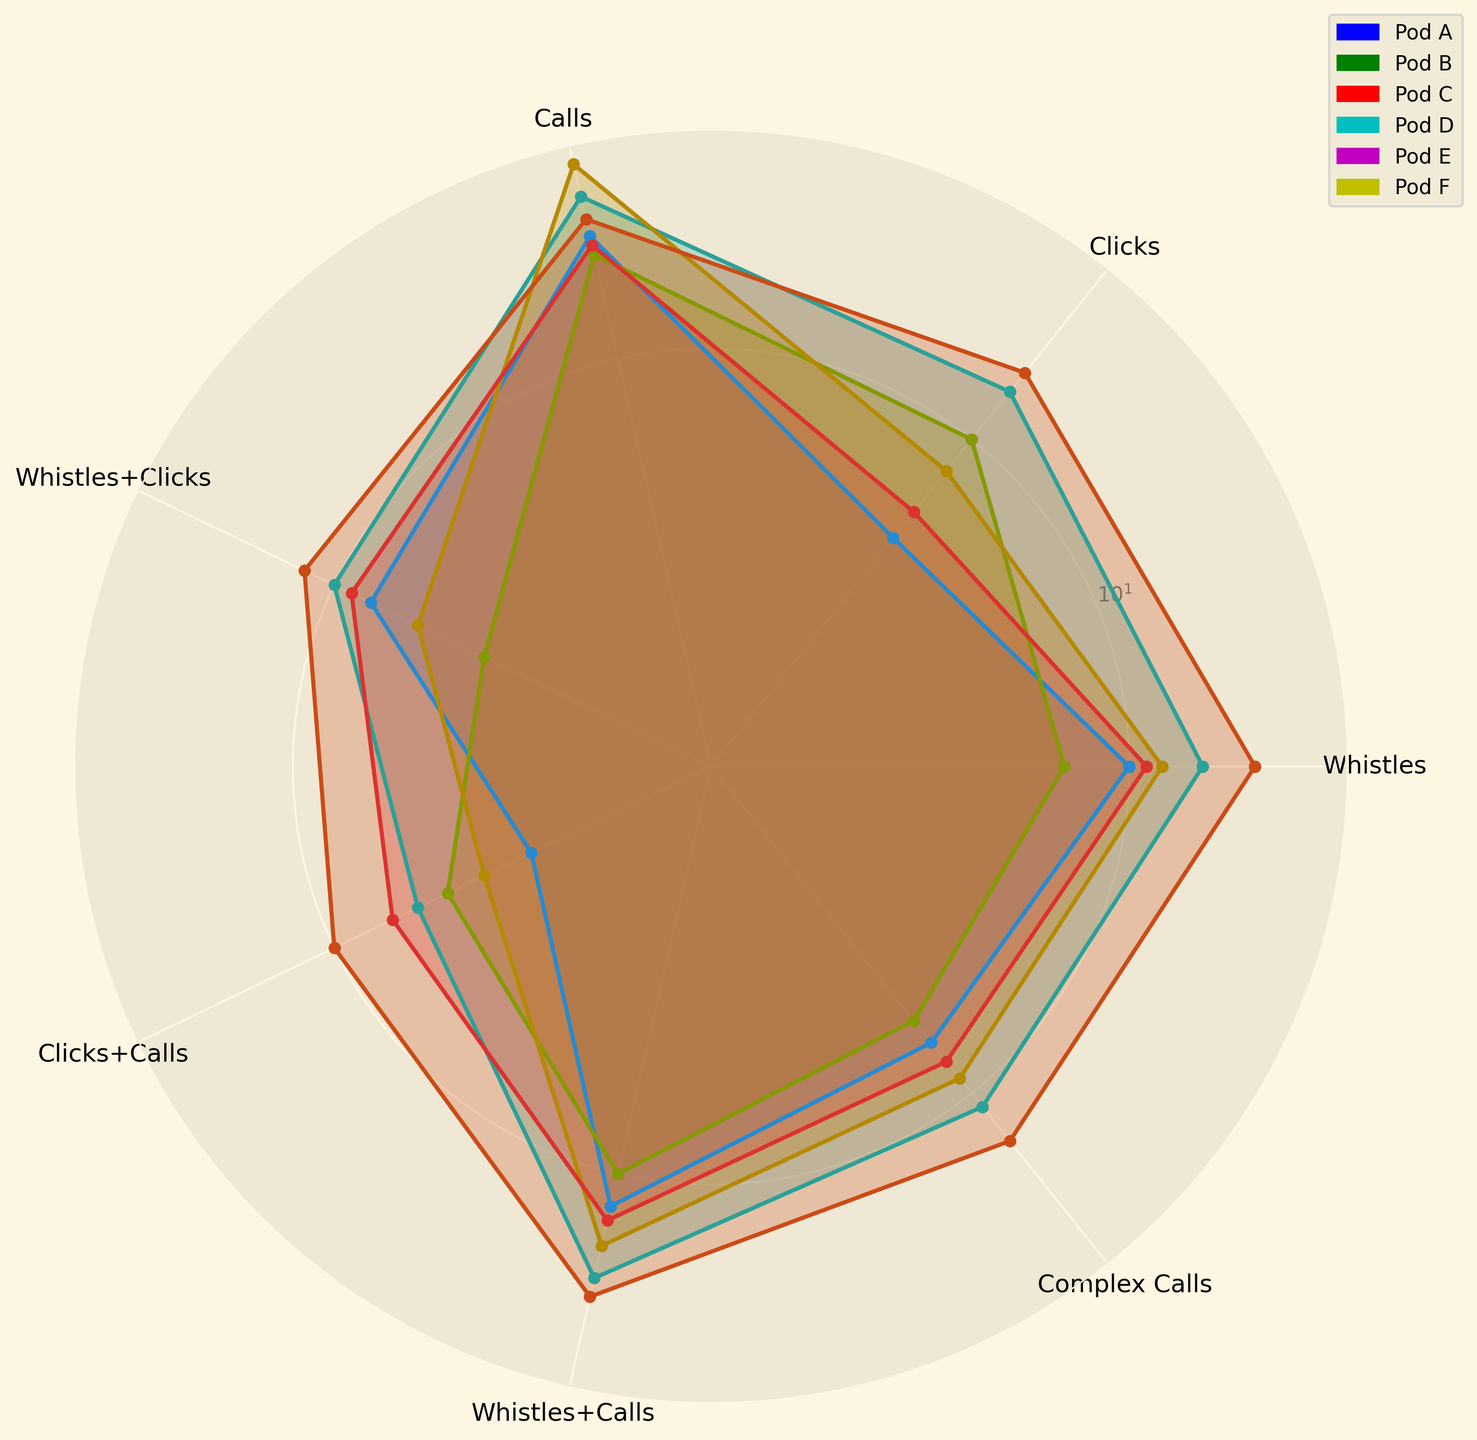What pod has the highest number of "Clicks"? From the radar chart, identify the pod with the longest radial length at the "Clicks" category.
Answer: Pod E Which pod shows the largest number of "Clicks + Calls" vocalizations? Observe the "Clicks + Calls" radial lengths and determine the longest one.
Answer: Pod E Calculate the sum of "Whistles + Calls" for Pod A and Pod D. Locate the "Whistles + Calls" values for Pod A and Pod D from the radar chart and add them: 12 (Pod A) + 15 (Pod D) = 27.
Answer: 27 Compare the number of "Whistles" between Pod B and Pod F. Which one is greater? Check the "Whistles" radial lengths for Pod B and Pod F and note that Pod B has a longer length.
Answer: Pod B What is the difference in the number of "Complex Calls" between Pod A and Pod E? Identify the "Complex Calls" radial lengths and subtract Pod A’s value from Pod E's value: 14 (Pod E) - 7 (Pod A) = 7.
Answer: 7 What pod has the lowest frequency of "Whistles + Clicks"? Identify the shortest radial length in the "Whistles + Clicks" category.
Answer: Pod C Find the pod with the median value of "Calls". From the radar chart, order the radial lengths for "Calls" and find the middle one: Pod D (30), Pod B (25), Pod E (22), Pod A (20), Pod F (19), and Pod C (18). The median is 21 (Pod E).
Answer: Pod E Which pod shows the greatest diversity (visual spread) among different vocalizations? Analyze overall spread across different categories and find the pod with the most variation in radial lengths.
Answer: Pod B Find the range of "Whistles" vocalizations across all pods. Identify the highest and lowest radial lengths in the "Whistles" category and calculate the range: 20 (Pod E) - 7 (Pod C) = 13.
Answer: 13 